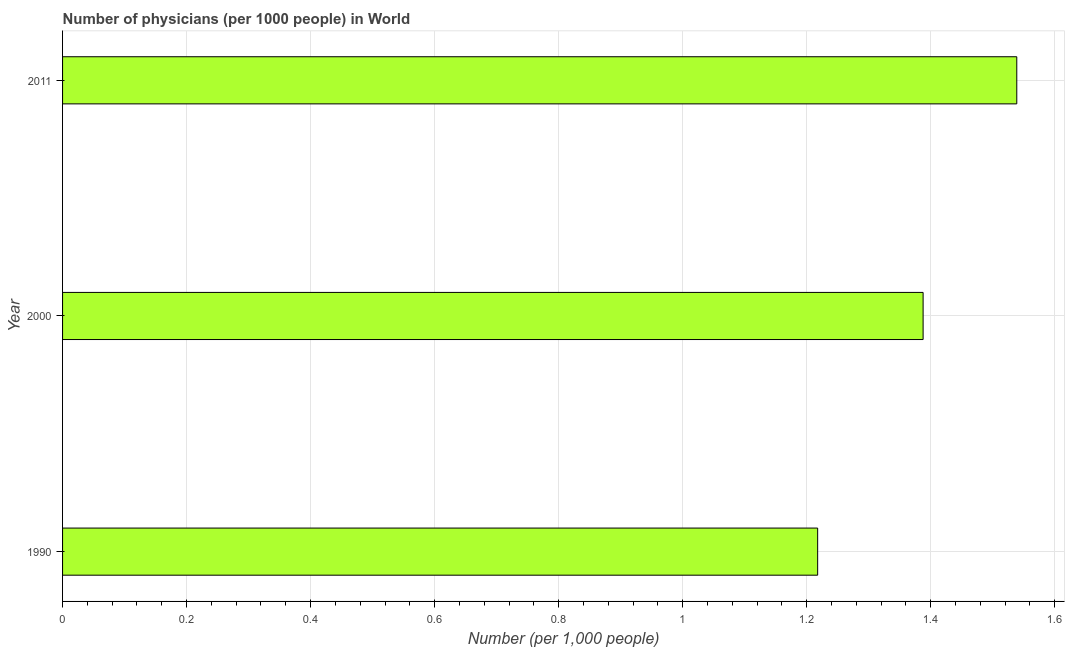What is the title of the graph?
Your response must be concise. Number of physicians (per 1000 people) in World. What is the label or title of the X-axis?
Provide a short and direct response. Number (per 1,0 people). What is the number of physicians in 1990?
Your answer should be compact. 1.22. Across all years, what is the maximum number of physicians?
Provide a short and direct response. 1.54. Across all years, what is the minimum number of physicians?
Your answer should be very brief. 1.22. In which year was the number of physicians minimum?
Your response must be concise. 1990. What is the sum of the number of physicians?
Your answer should be compact. 4.14. What is the difference between the number of physicians in 1990 and 2011?
Offer a very short reply. -0.32. What is the average number of physicians per year?
Provide a succinct answer. 1.38. What is the median number of physicians?
Keep it short and to the point. 1.39. In how many years, is the number of physicians greater than 0.36 ?
Offer a very short reply. 3. Do a majority of the years between 1990 and 2000 (inclusive) have number of physicians greater than 0.56 ?
Your answer should be very brief. Yes. What is the ratio of the number of physicians in 1990 to that in 2011?
Ensure brevity in your answer.  0.79. Is the number of physicians in 2000 less than that in 2011?
Keep it short and to the point. Yes. Is the difference between the number of physicians in 2000 and 2011 greater than the difference between any two years?
Your response must be concise. No. What is the difference between the highest and the second highest number of physicians?
Your response must be concise. 0.15. What is the difference between the highest and the lowest number of physicians?
Make the answer very short. 0.32. How many years are there in the graph?
Ensure brevity in your answer.  3. What is the difference between two consecutive major ticks on the X-axis?
Your answer should be very brief. 0.2. Are the values on the major ticks of X-axis written in scientific E-notation?
Offer a very short reply. No. What is the Number (per 1,000 people) of 1990?
Give a very brief answer. 1.22. What is the Number (per 1,000 people) of 2000?
Keep it short and to the point. 1.39. What is the Number (per 1,000 people) of 2011?
Offer a terse response. 1.54. What is the difference between the Number (per 1,000 people) in 1990 and 2000?
Provide a short and direct response. -0.17. What is the difference between the Number (per 1,000 people) in 1990 and 2011?
Make the answer very short. -0.32. What is the difference between the Number (per 1,000 people) in 2000 and 2011?
Give a very brief answer. -0.15. What is the ratio of the Number (per 1,000 people) in 1990 to that in 2000?
Make the answer very short. 0.88. What is the ratio of the Number (per 1,000 people) in 1990 to that in 2011?
Offer a terse response. 0.79. What is the ratio of the Number (per 1,000 people) in 2000 to that in 2011?
Offer a terse response. 0.9. 